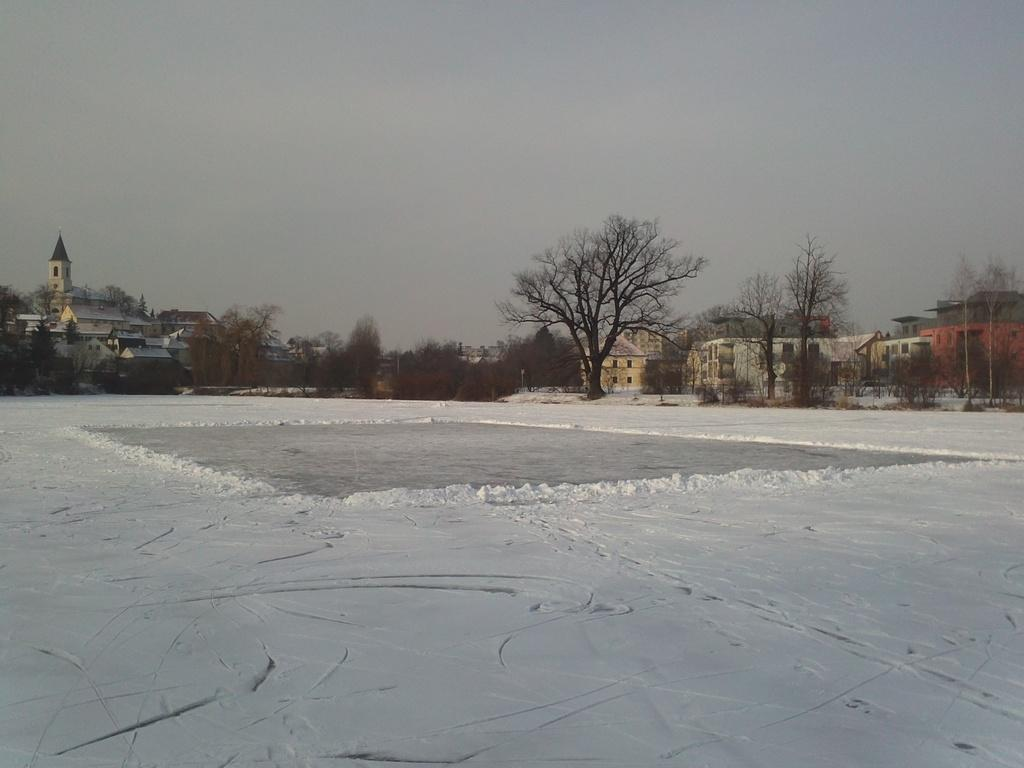What is covering the ground in the image? There is snow on the ground in the image. What else can be seen besides the snow? There is water visible in the image. What can be seen in the distance in the image? There are trees and buildings in the background of the image. What is visible above the trees and buildings in the image? The sky is visible in the image. What type of string can be seen holding the writer's pen in the image? There is no writer or pen present in the image, so there is no string holding a pen. 